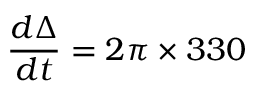<formula> <loc_0><loc_0><loc_500><loc_500>\frac { d \Delta } { d t } = 2 \pi \times 3 3 0</formula> 